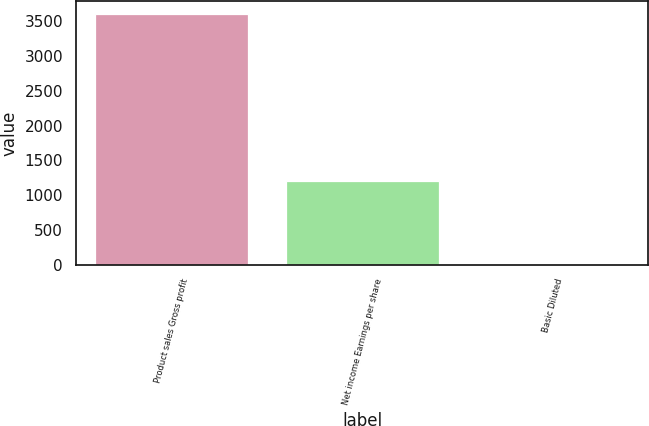Convert chart. <chart><loc_0><loc_0><loc_500><loc_500><bar_chart><fcel>Product sales Gross profit<fcel>Net income Earnings per share<fcel>Basic Diluted<nl><fcel>3613<fcel>1202<fcel>1.25<nl></chart> 